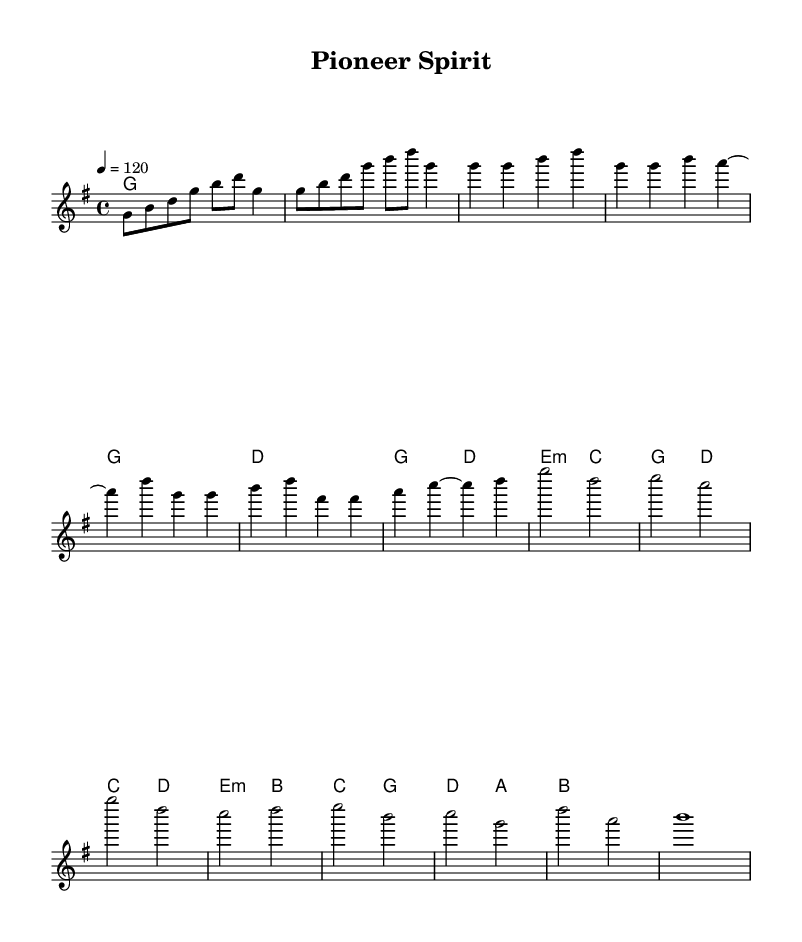What is the key signature of this music? The key signature is G major, which is indicated by one sharp in the notation. This means that the F notes are sharped throughout the piece.
Answer: G major What is the time signature of this music? The time signature is 4/4, which means there are four beats in each measure. This is indicated by the notation at the beginning, representing a common time signature used in many dances.
Answer: 4/4 What is the tempo marking of this piece? The tempo marking is indicated as 4 equals 120, meaning the quarter note is set at a tempo of 120 beats per minute. This implies that the piece should be played relatively briskly.
Answer: 120 How many measures are in the chorus section? The chorus section consists of four measures, as indicated by the grouping in the sheet music. Counting the measures in that section confirms this.
Answer: 4 What is the last note in the bridge? The last note in the bridge is b, which appears as a whole note at the end of the melodic line in that section. This conclusion is drawn from analyzing the melody staff.
Answer: b What are the first two chords played in the piece? The first two chords are G major and G major, as shown in the chord names section, which repeats before the verse begins. This shows the harmonic structure at the start.
Answer: G major, G major What kind of dance rhythm does this tune likely represent? The dance rhythm is likely to represent a lively folk dance, characterized by its upbeat tempo and folk-inspired melody and harmony. By interpreting the musical elements and their cultural connections, one can deduce this.
Answer: Folk dance 